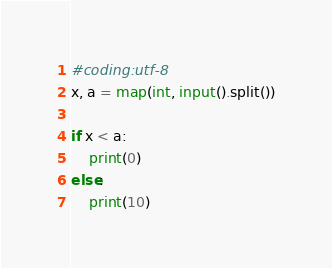<code> <loc_0><loc_0><loc_500><loc_500><_Python_>#coding:utf-8
x, a = map(int, input().split())

if x < a:
    print(0)
else:
    print(10)</code> 